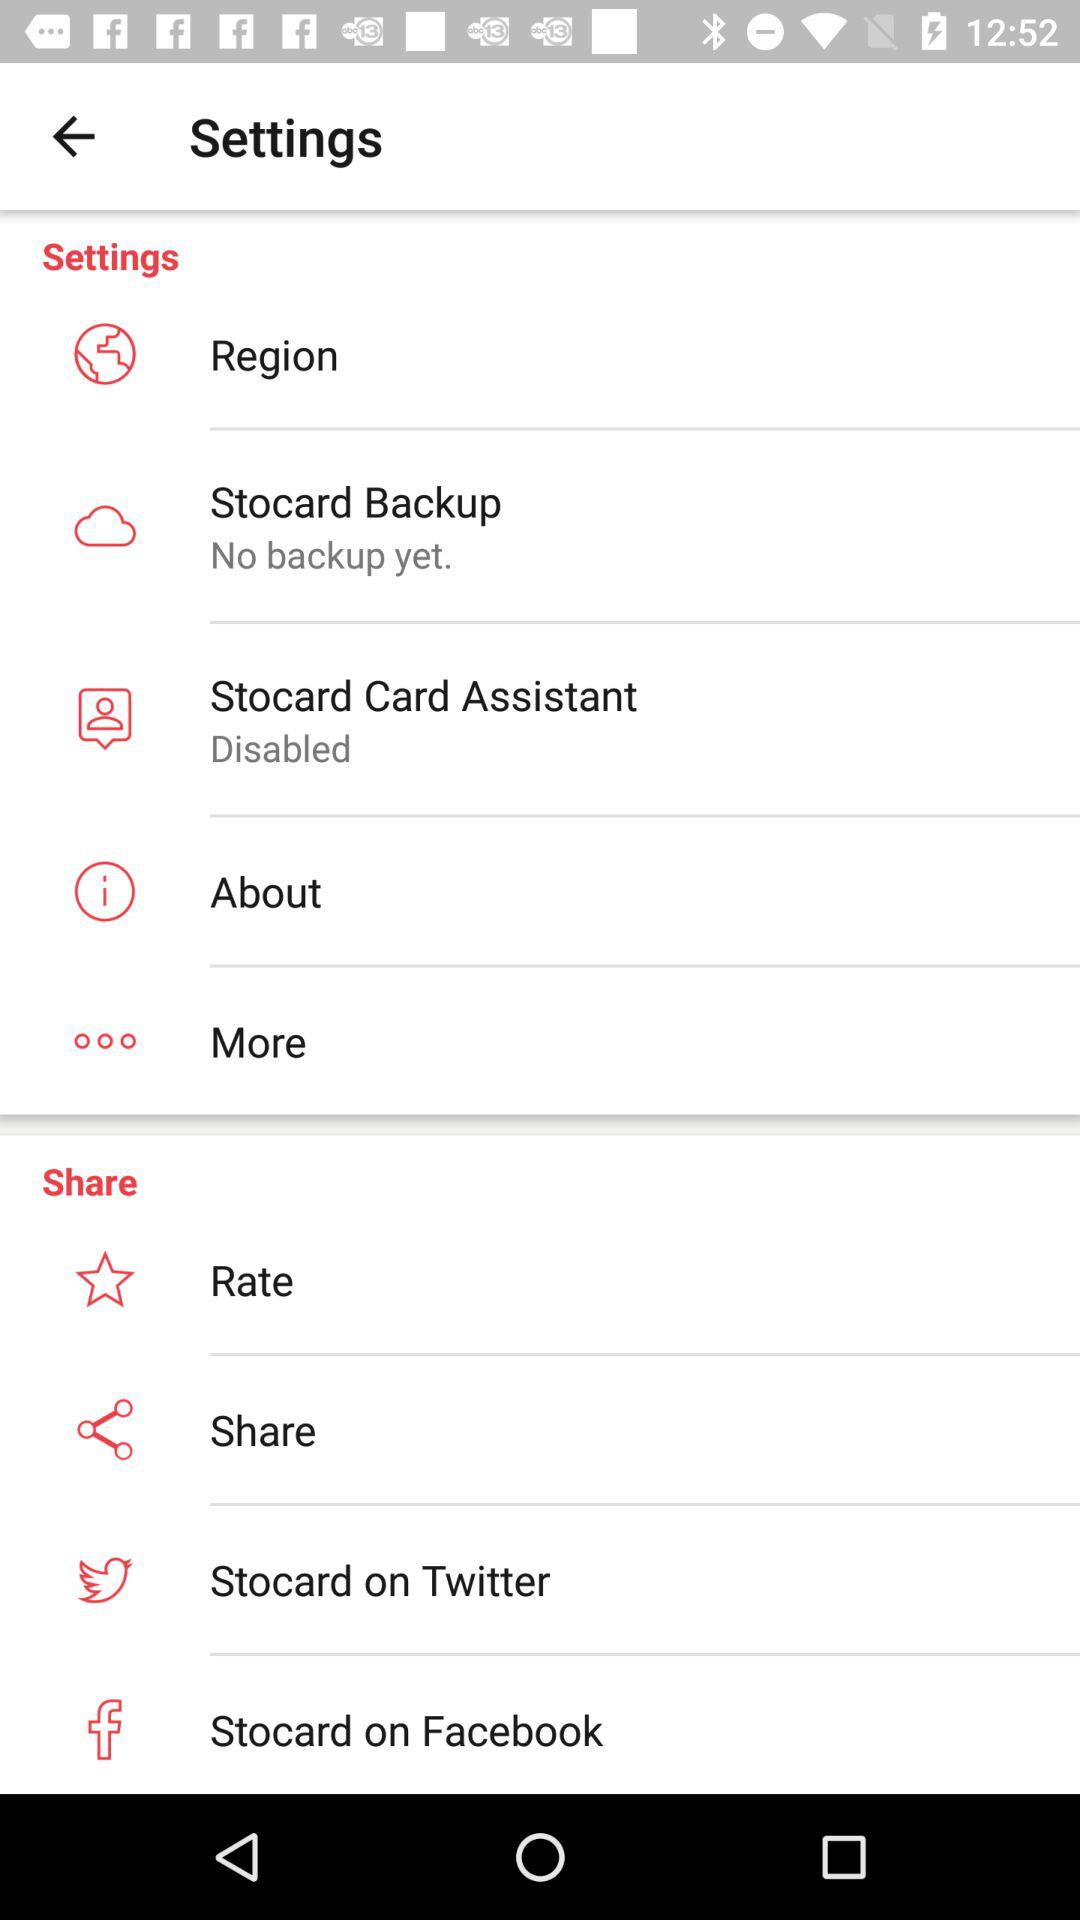Is the Stocard backup taken? The Stocard backup has not been taken yet. 